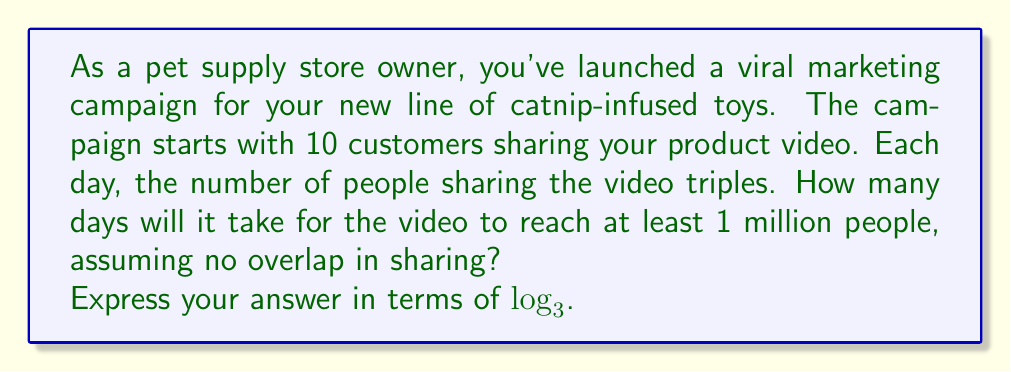Can you solve this math problem? Let's approach this step-by-step:

1) Let $n$ be the number of days.

2) The number of people reached after $n$ days can be expressed as:
   $10 \cdot 3^n$

3) We want to find when this number reaches or exceeds 1 million:
   $10 \cdot 3^n \geq 1,000,000$

4) Divide both sides by 10:
   $3^n \geq 100,000$

5) Take $\log_3$ of both sides:
   $\log_3(3^n) \geq \log_3(100,000)$

6) Simplify the left side using the logarithm property $\log_a(a^x) = x$:
   $n \geq \log_3(100,000)$

7) Since we need the smallest number of whole days, we need to round up to the next integer.

8) Therefore, the number of days is:
   $n = \lceil \log_3(100,000) \rceil$

Where $\lceil \rceil$ denotes the ceiling function (rounding up to the next integer).
Answer: $\lceil \log_3(100,000) \rceil$ days 